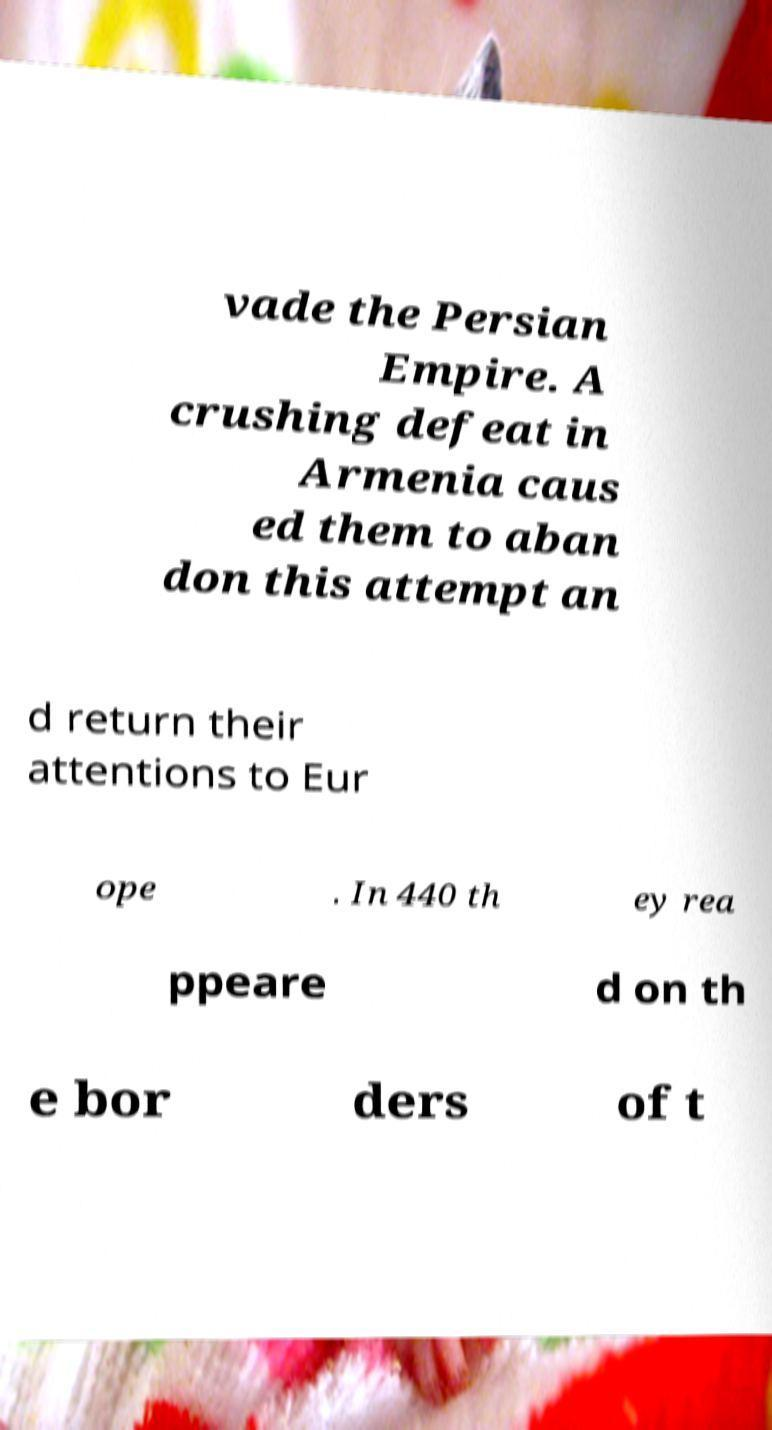Can you accurately transcribe the text from the provided image for me? vade the Persian Empire. A crushing defeat in Armenia caus ed them to aban don this attempt an d return their attentions to Eur ope . In 440 th ey rea ppeare d on th e bor ders of t 